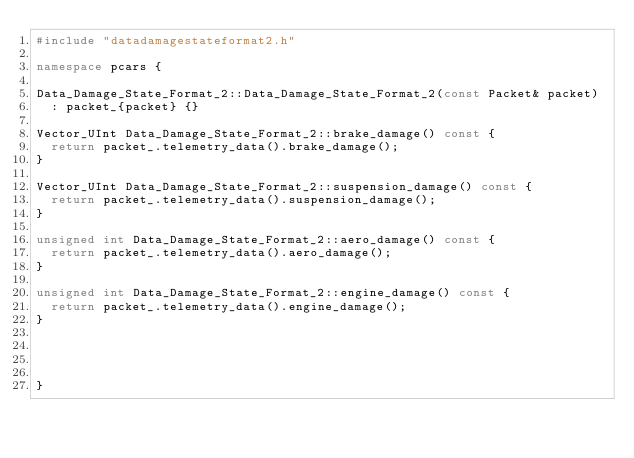Convert code to text. <code><loc_0><loc_0><loc_500><loc_500><_C++_>#include "datadamagestateformat2.h"

namespace pcars {

Data_Damage_State_Format_2::Data_Damage_State_Format_2(const Packet& packet)
	: packet_{packet} {}
	
Vector_UInt Data_Damage_State_Format_2::brake_damage() const {
	return packet_.telemetry_data().brake_damage();
}

Vector_UInt Data_Damage_State_Format_2::suspension_damage() const {
	return packet_.telemetry_data().suspension_damage();
}

unsigned int Data_Damage_State_Format_2::aero_damage() const {
	return packet_.telemetry_data().aero_damage();
}

unsigned int Data_Damage_State_Format_2::engine_damage() const {
	return packet_.telemetry_data().engine_damage();
}




}

</code> 